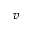<formula> <loc_0><loc_0><loc_500><loc_500>v</formula> 